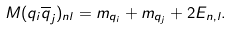Convert formula to latex. <formula><loc_0><loc_0><loc_500><loc_500>M ( q _ { i } \overline { q } _ { j } ) _ { n l } = m _ { q _ { i } } + m _ { q _ { j } } + 2 E _ { n , l } .</formula> 